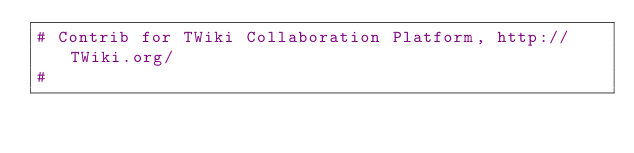<code> <loc_0><loc_0><loc_500><loc_500><_Perl_># Contrib for TWiki Collaboration Platform, http://TWiki.org/
#</code> 